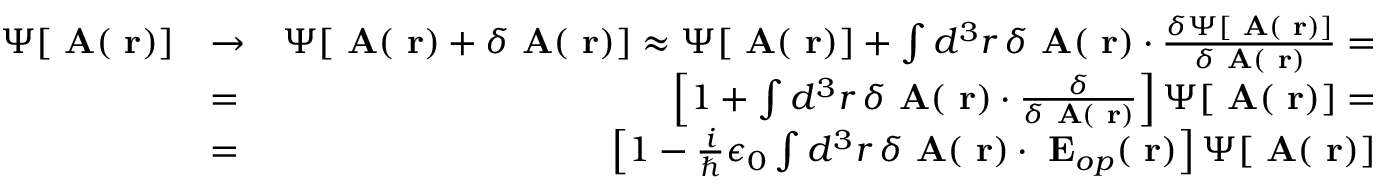Convert formula to latex. <formula><loc_0><loc_0><loc_500><loc_500>\begin{array} { r l r } { \Psi [ A ( r ) ] } & { \to } & { \Psi [ A ( r ) + \delta A ( r ) ] \approx \Psi [ A ( r ) ] + \int d ^ { 3 } r \, \delta A ( r ) \cdot \frac { \delta \Psi [ A ( r ) ] } { \delta A ( r ) } = } \\ & { = } & { \left [ 1 + \int d ^ { 3 } r \, \delta A ( r ) \cdot \frac { \delta } { \delta A ( r ) } \right ] \Psi [ A ( r ) ] = } \\ & { = } & { \left [ 1 - \frac { i } { } \epsilon _ { 0 } \int d ^ { 3 } r \, \delta A ( r ) \cdot E _ { o p } ( r ) \right ] \Psi [ A ( r ) ] } \end{array}</formula> 